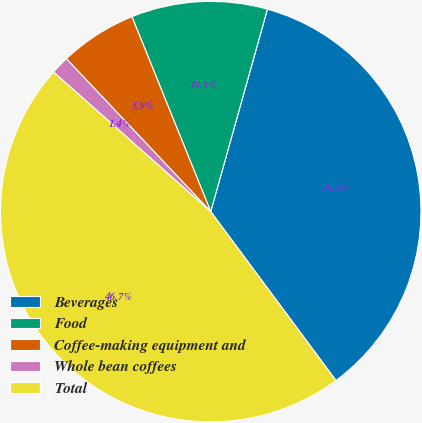<chart> <loc_0><loc_0><loc_500><loc_500><pie_chart><fcel>Beverages<fcel>Food<fcel>Coffee-making equipment and<fcel>Whole bean coffees<fcel>Total<nl><fcel>35.5%<fcel>10.46%<fcel>5.93%<fcel>1.4%<fcel>46.71%<nl></chart> 